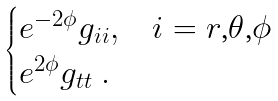Convert formula to latex. <formula><loc_0><loc_0><loc_500><loc_500>\begin{cases} e ^ { - 2 \phi } g _ { i i } , & \text {$i=r$,$\theta$,$\phi$} \\ e ^ { 2 \phi } g _ { t t } \ . \end{cases}</formula> 